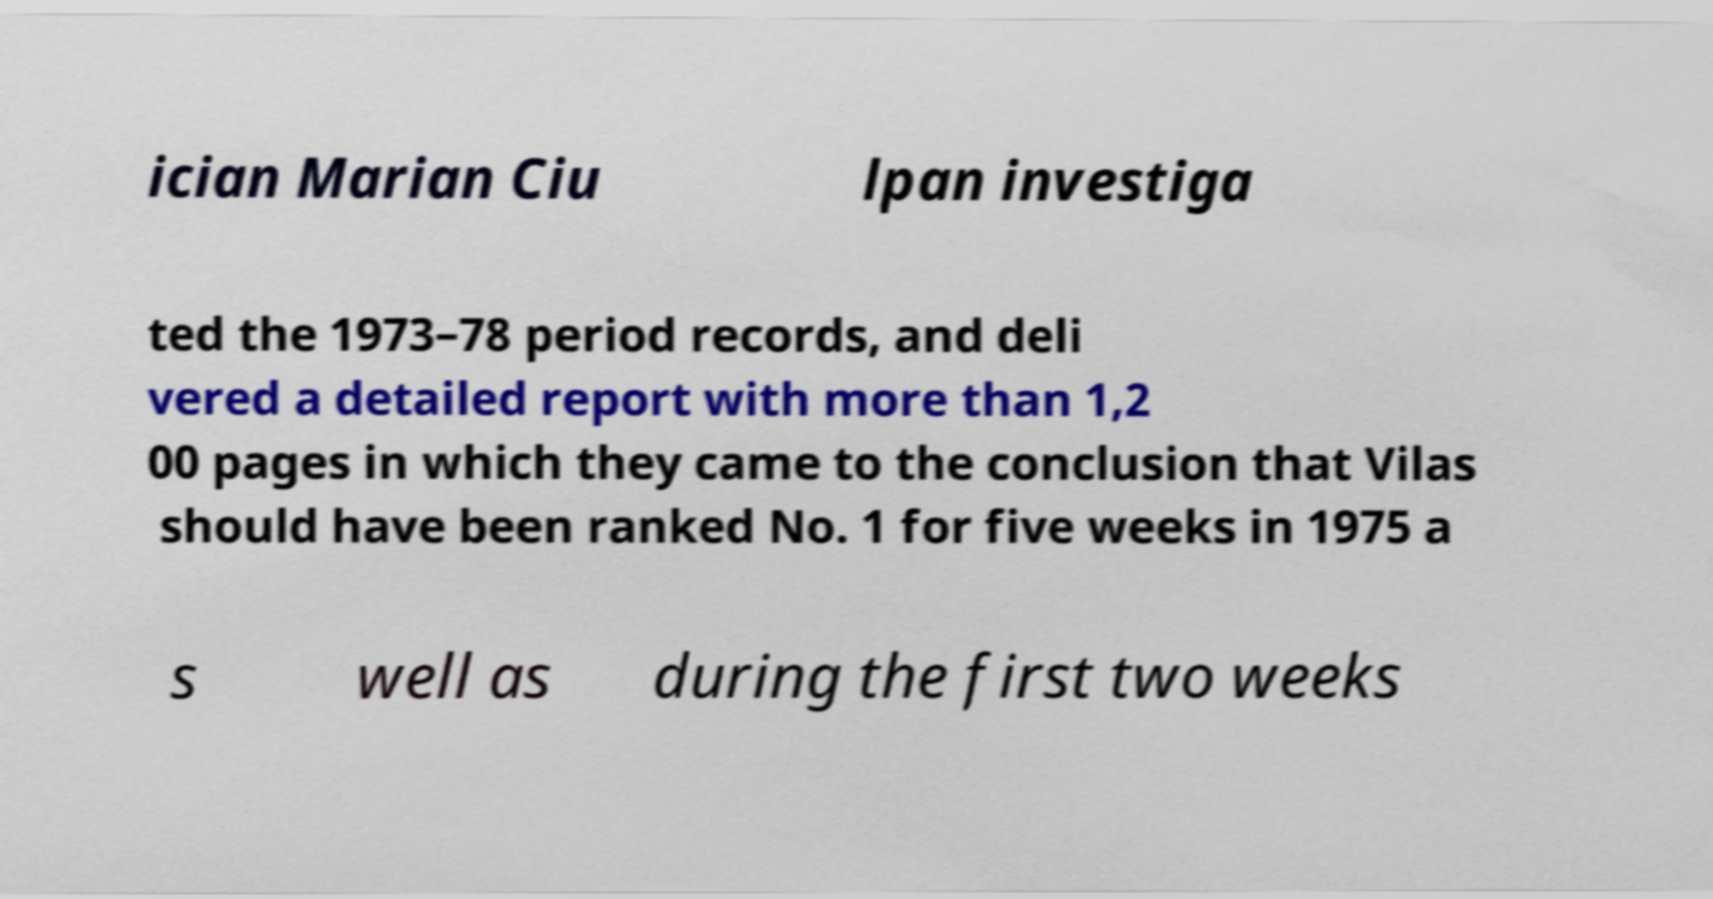Please identify and transcribe the text found in this image. ician Marian Ciu lpan investiga ted the 1973–78 period records, and deli vered a detailed report with more than 1,2 00 pages in which they came to the conclusion that Vilas should have been ranked No. 1 for five weeks in 1975 a s well as during the first two weeks 